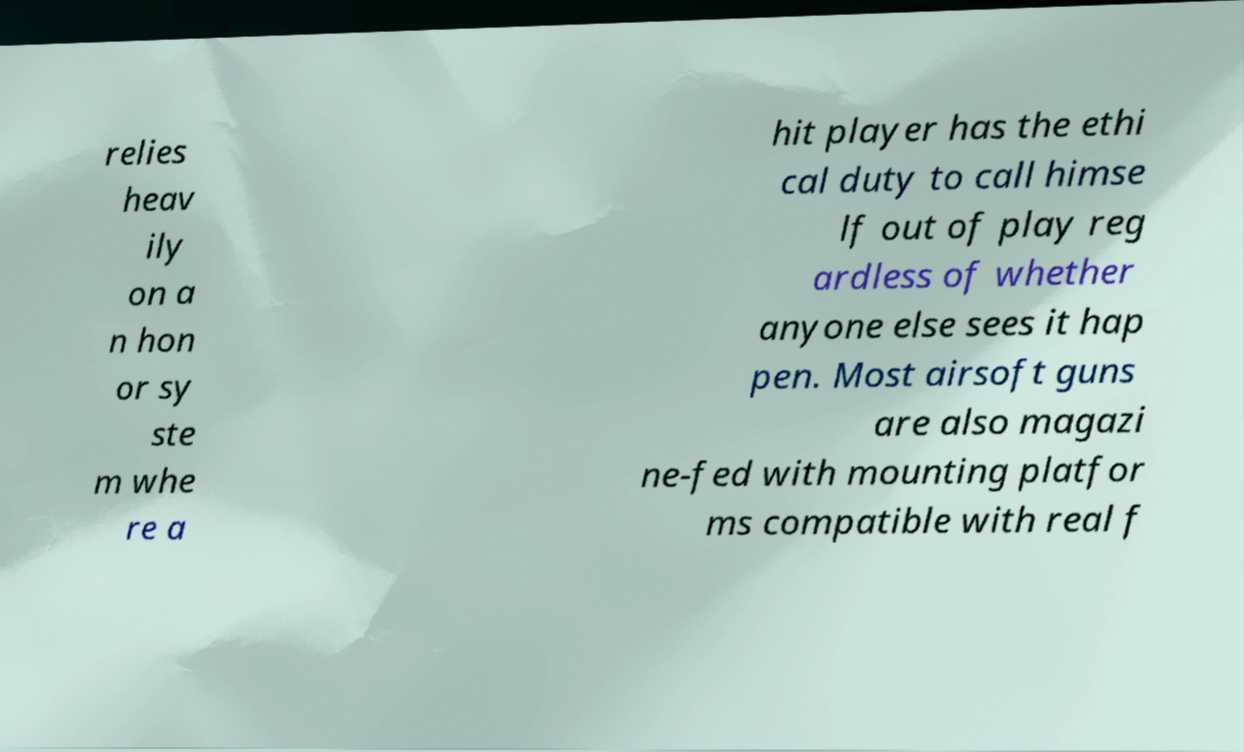For documentation purposes, I need the text within this image transcribed. Could you provide that? relies heav ily on a n hon or sy ste m whe re a hit player has the ethi cal duty to call himse lf out of play reg ardless of whether anyone else sees it hap pen. Most airsoft guns are also magazi ne-fed with mounting platfor ms compatible with real f 